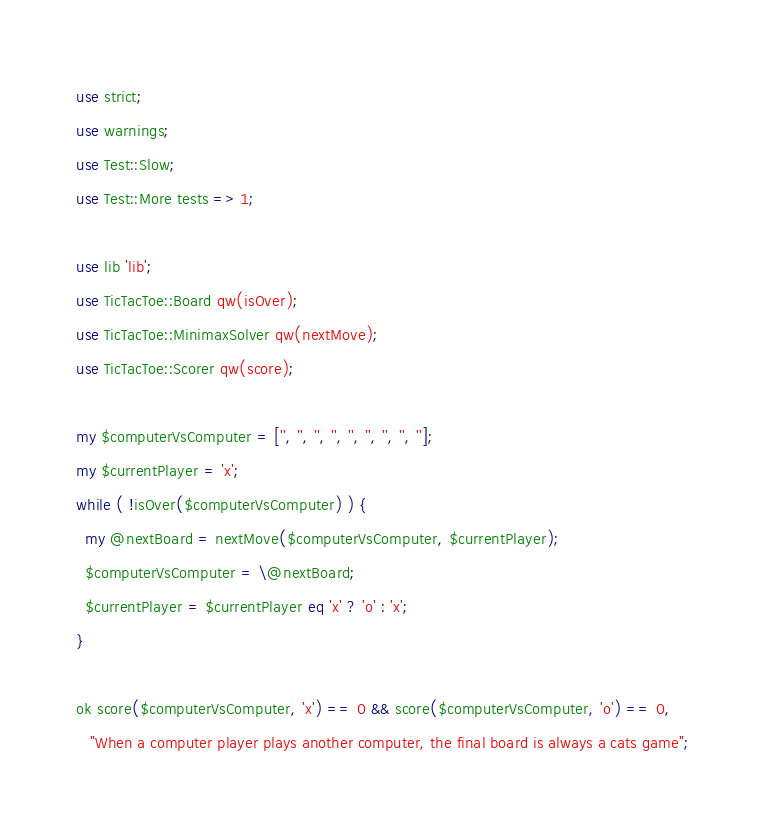Convert code to text. <code><loc_0><loc_0><loc_500><loc_500><_Perl_>use strict;
use warnings;
use Test::Slow;
use Test::More tests => 1;

use lib 'lib';
use TicTacToe::Board qw(isOver);
use TicTacToe::MinimaxSolver qw(nextMove);
use TicTacToe::Scorer qw(score);

my $computerVsComputer = ['', '', '', '', '', '', '', '', '']; 
my $currentPlayer = 'x';
while ( !isOver($computerVsComputer) ) {
  my @nextBoard = nextMove($computerVsComputer, $currentPlayer);
  $computerVsComputer = \@nextBoard;
  $currentPlayer = $currentPlayer eq 'x' ? 'o' : 'x';
}

ok score($computerVsComputer, 'x') == 0 && score($computerVsComputer, 'o') == 0,
   "When a computer player plays another computer, the final board is always a cats game";

</code> 